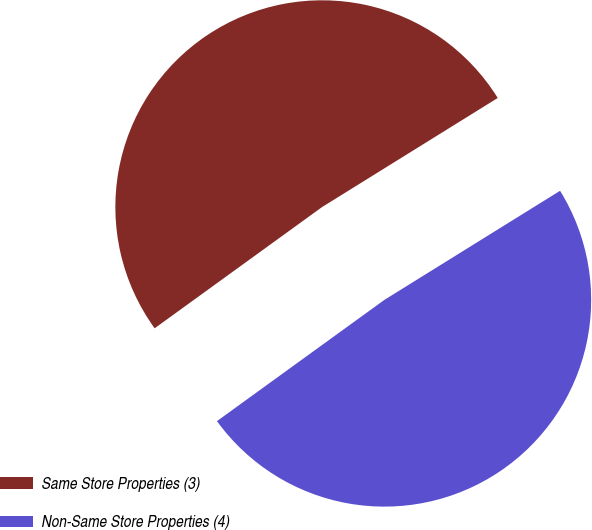Convert chart. <chart><loc_0><loc_0><loc_500><loc_500><pie_chart><fcel>Same Store Properties (3)<fcel>Non-Same Store Properties (4)<nl><fcel>51.13%<fcel>48.87%<nl></chart> 